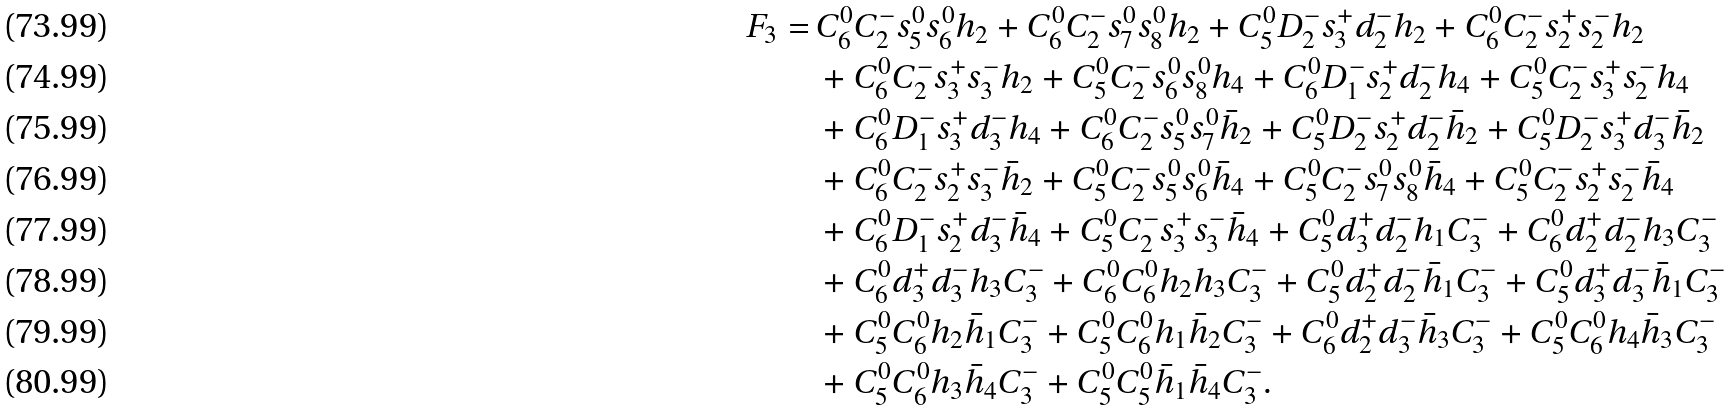<formula> <loc_0><loc_0><loc_500><loc_500>F _ { 3 } = \ & C ^ { 0 } _ { 6 } C ^ { - } _ { 2 } s ^ { 0 } _ { 5 } s ^ { 0 } _ { 6 } h _ { 2 } + C ^ { 0 } _ { 6 } C ^ { - } _ { 2 } s ^ { 0 } _ { 7 } s ^ { 0 } _ { 8 } h _ { 2 } + C ^ { 0 } _ { 5 } D ^ { - } _ { 2 } s ^ { + } _ { 3 } d ^ { - } _ { 2 } h _ { 2 } + C ^ { 0 } _ { 6 } C ^ { - } _ { 2 } s ^ { + } _ { 2 } s ^ { - } _ { 2 } h _ { 2 } \\ & + C ^ { 0 } _ { 6 } C ^ { - } _ { 2 } s ^ { + } _ { 3 } s ^ { - } _ { 3 } h _ { 2 } + C ^ { 0 } _ { 5 } C ^ { - } _ { 2 } s ^ { 0 } _ { 6 } s ^ { 0 } _ { 8 } h _ { 4 } + C ^ { 0 } _ { 6 } D ^ { - } _ { 1 } s ^ { + } _ { 2 } d ^ { - } _ { 2 } h _ { 4 } + C ^ { 0 } _ { 5 } C ^ { - } _ { 2 } s ^ { + } _ { 3 } s ^ { - } _ { 2 } h _ { 4 } \\ & + C ^ { 0 } _ { 6 } D ^ { - } _ { 1 } s ^ { + } _ { 3 } d ^ { - } _ { 3 } h _ { 4 } + C ^ { 0 } _ { 6 } C ^ { - } _ { 2 } s ^ { 0 } _ { 5 } s ^ { 0 } _ { 7 } \bar { h } _ { 2 } + C ^ { 0 } _ { 5 } D ^ { - } _ { 2 } s ^ { + } _ { 2 } d ^ { - } _ { 2 } \bar { h } _ { 2 } + C ^ { 0 } _ { 5 } D ^ { - } _ { 2 } s ^ { + } _ { 3 } d ^ { - } _ { 3 } \bar { h } _ { 2 } \\ & + C ^ { 0 } _ { 6 } C ^ { - } _ { 2 } s ^ { + } _ { 2 } s ^ { - } _ { 3 } \bar { h } _ { 2 } + C ^ { 0 } _ { 5 } C ^ { - } _ { 2 } s ^ { 0 } _ { 5 } s ^ { 0 } _ { 6 } \bar { h } _ { 4 } + C ^ { 0 } _ { 5 } C ^ { - } _ { 2 } s ^ { 0 } _ { 7 } s ^ { 0 } _ { 8 } \bar { h } _ { 4 } + C ^ { 0 } _ { 5 } C ^ { - } _ { 2 } s ^ { + } _ { 2 } s ^ { - } _ { 2 } \bar { h } _ { 4 } \\ & + C ^ { 0 } _ { 6 } D ^ { - } _ { 1 } s ^ { + } _ { 2 } d ^ { - } _ { 3 } \bar { h } _ { 4 } + C ^ { 0 } _ { 5 } C ^ { - } _ { 2 } s ^ { + } _ { 3 } s ^ { - } _ { 3 } \bar { h } _ { 4 } + C ^ { 0 } _ { 5 } d ^ { + } _ { 3 } d ^ { - } _ { 2 } h _ { 1 } C ^ { - } _ { 3 } + C ^ { 0 } _ { 6 } d ^ { + } _ { 2 } d ^ { - } _ { 2 } h _ { 3 } C ^ { - } _ { 3 } \\ & + C ^ { 0 } _ { 6 } d ^ { + } _ { 3 } d ^ { - } _ { 3 } h _ { 3 } C ^ { - } _ { 3 } + C ^ { 0 } _ { 6 } C ^ { 0 } _ { 6 } h _ { 2 } h _ { 3 } C ^ { - } _ { 3 } + C ^ { 0 } _ { 5 } d ^ { + } _ { 2 } d ^ { - } _ { 2 } \bar { h } _ { 1 } C ^ { - } _ { 3 } + C ^ { 0 } _ { 5 } d ^ { + } _ { 3 } d ^ { - } _ { 3 } \bar { h } _ { 1 } C ^ { - } _ { 3 } \\ & + C ^ { 0 } _ { 5 } C ^ { 0 } _ { 6 } h _ { 2 } \bar { h } _ { 1 } C ^ { - } _ { 3 } + C ^ { 0 } _ { 5 } C ^ { 0 } _ { 6 } h _ { 1 } \bar { h } _ { 2 } C ^ { - } _ { 3 } + C ^ { 0 } _ { 6 } d ^ { + } _ { 2 } d ^ { - } _ { 3 } \bar { h } _ { 3 } C ^ { - } _ { 3 } + C ^ { 0 } _ { 5 } C ^ { 0 } _ { 6 } h _ { 4 } \bar { h } _ { 3 } C ^ { - } _ { 3 } \\ & + C ^ { 0 } _ { 5 } C ^ { 0 } _ { 6 } h _ { 3 } \bar { h } _ { 4 } C ^ { - } _ { 3 } + C ^ { 0 } _ { 5 } C ^ { 0 } _ { 5 } \bar { h } _ { 1 } \bar { h } _ { 4 } C ^ { - } _ { 3 } .</formula> 